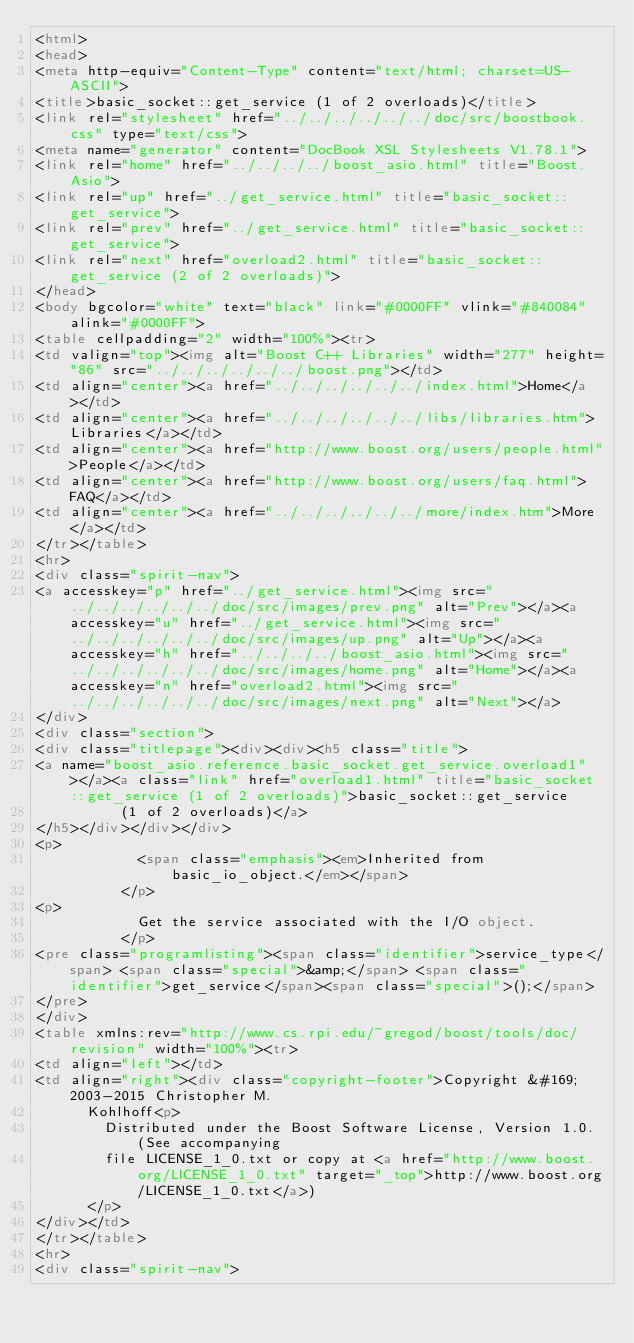<code> <loc_0><loc_0><loc_500><loc_500><_HTML_><html>
<head>
<meta http-equiv="Content-Type" content="text/html; charset=US-ASCII">
<title>basic_socket::get_service (1 of 2 overloads)</title>
<link rel="stylesheet" href="../../../../../../doc/src/boostbook.css" type="text/css">
<meta name="generator" content="DocBook XSL Stylesheets V1.78.1">
<link rel="home" href="../../../../boost_asio.html" title="Boost.Asio">
<link rel="up" href="../get_service.html" title="basic_socket::get_service">
<link rel="prev" href="../get_service.html" title="basic_socket::get_service">
<link rel="next" href="overload2.html" title="basic_socket::get_service (2 of 2 overloads)">
</head>
<body bgcolor="white" text="black" link="#0000FF" vlink="#840084" alink="#0000FF">
<table cellpadding="2" width="100%"><tr>
<td valign="top"><img alt="Boost C++ Libraries" width="277" height="86" src="../../../../../../boost.png"></td>
<td align="center"><a href="../../../../../../index.html">Home</a></td>
<td align="center"><a href="../../../../../../libs/libraries.htm">Libraries</a></td>
<td align="center"><a href="http://www.boost.org/users/people.html">People</a></td>
<td align="center"><a href="http://www.boost.org/users/faq.html">FAQ</a></td>
<td align="center"><a href="../../../../../../more/index.htm">More</a></td>
</tr></table>
<hr>
<div class="spirit-nav">
<a accesskey="p" href="../get_service.html"><img src="../../../../../../doc/src/images/prev.png" alt="Prev"></a><a accesskey="u" href="../get_service.html"><img src="../../../../../../doc/src/images/up.png" alt="Up"></a><a accesskey="h" href="../../../../boost_asio.html"><img src="../../../../../../doc/src/images/home.png" alt="Home"></a><a accesskey="n" href="overload2.html"><img src="../../../../../../doc/src/images/next.png" alt="Next"></a>
</div>
<div class="section">
<div class="titlepage"><div><div><h5 class="title">
<a name="boost_asio.reference.basic_socket.get_service.overload1"></a><a class="link" href="overload1.html" title="basic_socket::get_service (1 of 2 overloads)">basic_socket::get_service
          (1 of 2 overloads)</a>
</h5></div></div></div>
<p>
            <span class="emphasis"><em>Inherited from basic_io_object.</em></span>
          </p>
<p>
            Get the service associated with the I/O object.
          </p>
<pre class="programlisting"><span class="identifier">service_type</span> <span class="special">&amp;</span> <span class="identifier">get_service</span><span class="special">();</span>
</pre>
</div>
<table xmlns:rev="http://www.cs.rpi.edu/~gregod/boost/tools/doc/revision" width="100%"><tr>
<td align="left"></td>
<td align="right"><div class="copyright-footer">Copyright &#169; 2003-2015 Christopher M.
      Kohlhoff<p>
        Distributed under the Boost Software License, Version 1.0. (See accompanying
        file LICENSE_1_0.txt or copy at <a href="http://www.boost.org/LICENSE_1_0.txt" target="_top">http://www.boost.org/LICENSE_1_0.txt</a>)
      </p>
</div></td>
</tr></table>
<hr>
<div class="spirit-nav"></code> 